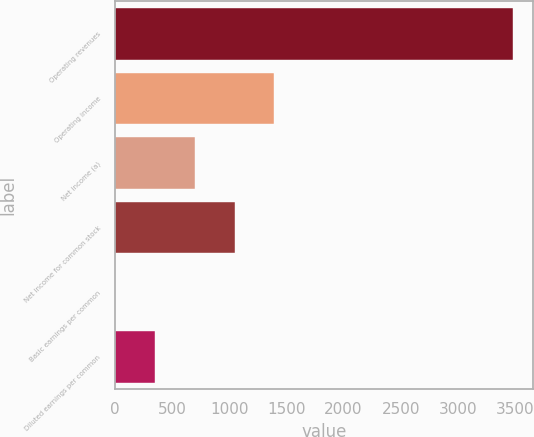Convert chart. <chart><loc_0><loc_0><loc_500><loc_500><bar_chart><fcel>Operating revenues<fcel>Operating income<fcel>Net income (a)<fcel>Net income for common stock<fcel>Basic earnings per common<fcel>Diluted earnings per common<nl><fcel>3484<fcel>1394.54<fcel>698.06<fcel>1046.3<fcel>1.58<fcel>349.82<nl></chart> 